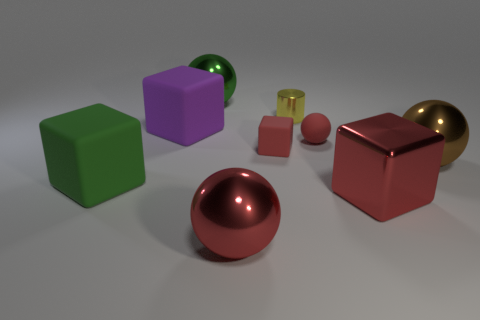Subtract all yellow cubes. Subtract all red cylinders. How many cubes are left? 4 Add 1 brown spheres. How many objects exist? 10 Subtract all cubes. How many objects are left? 5 Subtract all large red metallic blocks. Subtract all purple objects. How many objects are left? 7 Add 1 red rubber cubes. How many red rubber cubes are left? 2 Add 1 tiny gray balls. How many tiny gray balls exist? 1 Subtract 0 brown blocks. How many objects are left? 9 